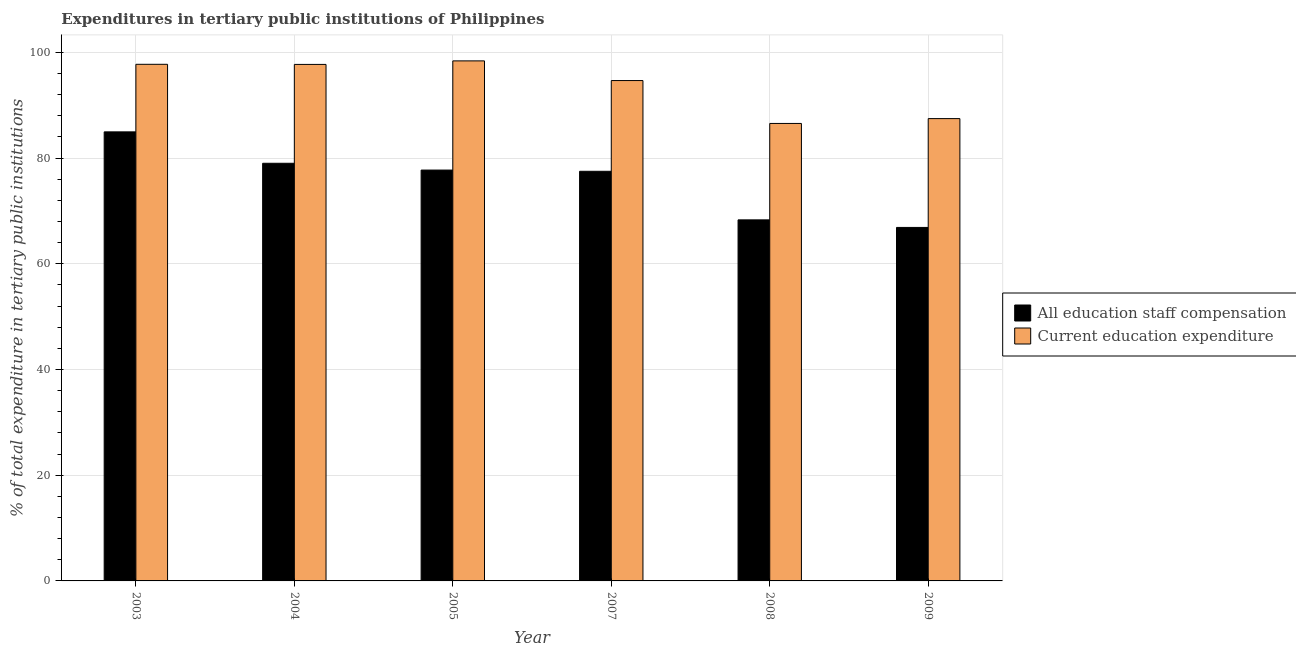How many groups of bars are there?
Provide a short and direct response. 6. Are the number of bars per tick equal to the number of legend labels?
Offer a terse response. Yes. Are the number of bars on each tick of the X-axis equal?
Your answer should be compact. Yes. How many bars are there on the 2nd tick from the left?
Ensure brevity in your answer.  2. How many bars are there on the 2nd tick from the right?
Provide a succinct answer. 2. What is the expenditure in staff compensation in 2004?
Your answer should be very brief. 79.01. Across all years, what is the maximum expenditure in education?
Your answer should be very brief. 98.39. Across all years, what is the minimum expenditure in education?
Your answer should be very brief. 86.55. What is the total expenditure in staff compensation in the graph?
Your answer should be compact. 454.38. What is the difference between the expenditure in staff compensation in 2007 and that in 2009?
Your response must be concise. 10.62. What is the difference between the expenditure in staff compensation in 2003 and the expenditure in education in 2004?
Provide a succinct answer. 5.94. What is the average expenditure in education per year?
Provide a succinct answer. 93.75. In the year 2004, what is the difference between the expenditure in education and expenditure in staff compensation?
Give a very brief answer. 0. In how many years, is the expenditure in education greater than 84 %?
Offer a very short reply. 6. What is the ratio of the expenditure in staff compensation in 2003 to that in 2005?
Provide a short and direct response. 1.09. What is the difference between the highest and the second highest expenditure in education?
Make the answer very short. 0.65. What is the difference between the highest and the lowest expenditure in staff compensation?
Offer a terse response. 18.08. What does the 1st bar from the left in 2009 represents?
Your answer should be compact. All education staff compensation. What does the 1st bar from the right in 2008 represents?
Give a very brief answer. Current education expenditure. Does the graph contain any zero values?
Provide a succinct answer. No. How many legend labels are there?
Offer a very short reply. 2. How are the legend labels stacked?
Your answer should be compact. Vertical. What is the title of the graph?
Give a very brief answer. Expenditures in tertiary public institutions of Philippines. What is the label or title of the Y-axis?
Offer a terse response. % of total expenditure in tertiary public institutions. What is the % of total expenditure in tertiary public institutions of All education staff compensation in 2003?
Provide a succinct answer. 84.95. What is the % of total expenditure in tertiary public institutions in Current education expenditure in 2003?
Your answer should be very brief. 97.74. What is the % of total expenditure in tertiary public institutions in All education staff compensation in 2004?
Offer a terse response. 79.01. What is the % of total expenditure in tertiary public institutions in Current education expenditure in 2004?
Your answer should be compact. 97.72. What is the % of total expenditure in tertiary public institutions of All education staff compensation in 2005?
Your answer should be compact. 77.73. What is the % of total expenditure in tertiary public institutions of Current education expenditure in 2005?
Your answer should be very brief. 98.39. What is the % of total expenditure in tertiary public institutions in All education staff compensation in 2007?
Provide a short and direct response. 77.5. What is the % of total expenditure in tertiary public institutions of Current education expenditure in 2007?
Ensure brevity in your answer.  94.66. What is the % of total expenditure in tertiary public institutions in All education staff compensation in 2008?
Your answer should be compact. 68.31. What is the % of total expenditure in tertiary public institutions in Current education expenditure in 2008?
Your answer should be compact. 86.55. What is the % of total expenditure in tertiary public institutions of All education staff compensation in 2009?
Your response must be concise. 66.88. What is the % of total expenditure in tertiary public institutions in Current education expenditure in 2009?
Your answer should be compact. 87.46. Across all years, what is the maximum % of total expenditure in tertiary public institutions in All education staff compensation?
Provide a succinct answer. 84.95. Across all years, what is the maximum % of total expenditure in tertiary public institutions of Current education expenditure?
Your answer should be very brief. 98.39. Across all years, what is the minimum % of total expenditure in tertiary public institutions of All education staff compensation?
Ensure brevity in your answer.  66.88. Across all years, what is the minimum % of total expenditure in tertiary public institutions of Current education expenditure?
Provide a short and direct response. 86.55. What is the total % of total expenditure in tertiary public institutions in All education staff compensation in the graph?
Provide a succinct answer. 454.38. What is the total % of total expenditure in tertiary public institutions of Current education expenditure in the graph?
Your answer should be very brief. 562.51. What is the difference between the % of total expenditure in tertiary public institutions of All education staff compensation in 2003 and that in 2004?
Offer a very short reply. 5.94. What is the difference between the % of total expenditure in tertiary public institutions in Current education expenditure in 2003 and that in 2004?
Your answer should be compact. 0.02. What is the difference between the % of total expenditure in tertiary public institutions of All education staff compensation in 2003 and that in 2005?
Give a very brief answer. 7.23. What is the difference between the % of total expenditure in tertiary public institutions of Current education expenditure in 2003 and that in 2005?
Your answer should be very brief. -0.65. What is the difference between the % of total expenditure in tertiary public institutions in All education staff compensation in 2003 and that in 2007?
Provide a succinct answer. 7.46. What is the difference between the % of total expenditure in tertiary public institutions in Current education expenditure in 2003 and that in 2007?
Your answer should be very brief. 3.07. What is the difference between the % of total expenditure in tertiary public institutions in All education staff compensation in 2003 and that in 2008?
Ensure brevity in your answer.  16.65. What is the difference between the % of total expenditure in tertiary public institutions in Current education expenditure in 2003 and that in 2008?
Ensure brevity in your answer.  11.19. What is the difference between the % of total expenditure in tertiary public institutions of All education staff compensation in 2003 and that in 2009?
Ensure brevity in your answer.  18.08. What is the difference between the % of total expenditure in tertiary public institutions of Current education expenditure in 2003 and that in 2009?
Your response must be concise. 10.27. What is the difference between the % of total expenditure in tertiary public institutions in All education staff compensation in 2004 and that in 2005?
Give a very brief answer. 1.28. What is the difference between the % of total expenditure in tertiary public institutions in Current education expenditure in 2004 and that in 2005?
Offer a terse response. -0.67. What is the difference between the % of total expenditure in tertiary public institutions of All education staff compensation in 2004 and that in 2007?
Make the answer very short. 1.52. What is the difference between the % of total expenditure in tertiary public institutions of Current education expenditure in 2004 and that in 2007?
Ensure brevity in your answer.  3.05. What is the difference between the % of total expenditure in tertiary public institutions in All education staff compensation in 2004 and that in 2008?
Offer a terse response. 10.71. What is the difference between the % of total expenditure in tertiary public institutions of Current education expenditure in 2004 and that in 2008?
Your answer should be compact. 11.17. What is the difference between the % of total expenditure in tertiary public institutions of All education staff compensation in 2004 and that in 2009?
Provide a succinct answer. 12.14. What is the difference between the % of total expenditure in tertiary public institutions in Current education expenditure in 2004 and that in 2009?
Keep it short and to the point. 10.25. What is the difference between the % of total expenditure in tertiary public institutions in All education staff compensation in 2005 and that in 2007?
Your answer should be compact. 0.23. What is the difference between the % of total expenditure in tertiary public institutions in Current education expenditure in 2005 and that in 2007?
Your response must be concise. 3.72. What is the difference between the % of total expenditure in tertiary public institutions in All education staff compensation in 2005 and that in 2008?
Offer a terse response. 9.42. What is the difference between the % of total expenditure in tertiary public institutions of Current education expenditure in 2005 and that in 2008?
Your answer should be compact. 11.84. What is the difference between the % of total expenditure in tertiary public institutions of All education staff compensation in 2005 and that in 2009?
Make the answer very short. 10.85. What is the difference between the % of total expenditure in tertiary public institutions in Current education expenditure in 2005 and that in 2009?
Provide a succinct answer. 10.92. What is the difference between the % of total expenditure in tertiary public institutions in All education staff compensation in 2007 and that in 2008?
Give a very brief answer. 9.19. What is the difference between the % of total expenditure in tertiary public institutions of Current education expenditure in 2007 and that in 2008?
Make the answer very short. 8.11. What is the difference between the % of total expenditure in tertiary public institutions in All education staff compensation in 2007 and that in 2009?
Keep it short and to the point. 10.62. What is the difference between the % of total expenditure in tertiary public institutions of Current education expenditure in 2007 and that in 2009?
Make the answer very short. 7.2. What is the difference between the % of total expenditure in tertiary public institutions of All education staff compensation in 2008 and that in 2009?
Your answer should be very brief. 1.43. What is the difference between the % of total expenditure in tertiary public institutions of Current education expenditure in 2008 and that in 2009?
Provide a succinct answer. -0.91. What is the difference between the % of total expenditure in tertiary public institutions of All education staff compensation in 2003 and the % of total expenditure in tertiary public institutions of Current education expenditure in 2004?
Your answer should be compact. -12.76. What is the difference between the % of total expenditure in tertiary public institutions in All education staff compensation in 2003 and the % of total expenditure in tertiary public institutions in Current education expenditure in 2005?
Offer a very short reply. -13.43. What is the difference between the % of total expenditure in tertiary public institutions in All education staff compensation in 2003 and the % of total expenditure in tertiary public institutions in Current education expenditure in 2007?
Keep it short and to the point. -9.71. What is the difference between the % of total expenditure in tertiary public institutions of All education staff compensation in 2003 and the % of total expenditure in tertiary public institutions of Current education expenditure in 2008?
Offer a terse response. -1.6. What is the difference between the % of total expenditure in tertiary public institutions of All education staff compensation in 2003 and the % of total expenditure in tertiary public institutions of Current education expenditure in 2009?
Your answer should be very brief. -2.51. What is the difference between the % of total expenditure in tertiary public institutions of All education staff compensation in 2004 and the % of total expenditure in tertiary public institutions of Current education expenditure in 2005?
Offer a very short reply. -19.37. What is the difference between the % of total expenditure in tertiary public institutions of All education staff compensation in 2004 and the % of total expenditure in tertiary public institutions of Current education expenditure in 2007?
Provide a succinct answer. -15.65. What is the difference between the % of total expenditure in tertiary public institutions of All education staff compensation in 2004 and the % of total expenditure in tertiary public institutions of Current education expenditure in 2008?
Your response must be concise. -7.54. What is the difference between the % of total expenditure in tertiary public institutions of All education staff compensation in 2004 and the % of total expenditure in tertiary public institutions of Current education expenditure in 2009?
Ensure brevity in your answer.  -8.45. What is the difference between the % of total expenditure in tertiary public institutions in All education staff compensation in 2005 and the % of total expenditure in tertiary public institutions in Current education expenditure in 2007?
Your answer should be compact. -16.93. What is the difference between the % of total expenditure in tertiary public institutions of All education staff compensation in 2005 and the % of total expenditure in tertiary public institutions of Current education expenditure in 2008?
Your answer should be very brief. -8.82. What is the difference between the % of total expenditure in tertiary public institutions in All education staff compensation in 2005 and the % of total expenditure in tertiary public institutions in Current education expenditure in 2009?
Your response must be concise. -9.74. What is the difference between the % of total expenditure in tertiary public institutions in All education staff compensation in 2007 and the % of total expenditure in tertiary public institutions in Current education expenditure in 2008?
Offer a very short reply. -9.05. What is the difference between the % of total expenditure in tertiary public institutions in All education staff compensation in 2007 and the % of total expenditure in tertiary public institutions in Current education expenditure in 2009?
Give a very brief answer. -9.97. What is the difference between the % of total expenditure in tertiary public institutions of All education staff compensation in 2008 and the % of total expenditure in tertiary public institutions of Current education expenditure in 2009?
Ensure brevity in your answer.  -19.16. What is the average % of total expenditure in tertiary public institutions in All education staff compensation per year?
Offer a terse response. 75.73. What is the average % of total expenditure in tertiary public institutions of Current education expenditure per year?
Your response must be concise. 93.75. In the year 2003, what is the difference between the % of total expenditure in tertiary public institutions of All education staff compensation and % of total expenditure in tertiary public institutions of Current education expenditure?
Provide a short and direct response. -12.78. In the year 2004, what is the difference between the % of total expenditure in tertiary public institutions in All education staff compensation and % of total expenditure in tertiary public institutions in Current education expenditure?
Your answer should be very brief. -18.7. In the year 2005, what is the difference between the % of total expenditure in tertiary public institutions of All education staff compensation and % of total expenditure in tertiary public institutions of Current education expenditure?
Your answer should be very brief. -20.66. In the year 2007, what is the difference between the % of total expenditure in tertiary public institutions in All education staff compensation and % of total expenditure in tertiary public institutions in Current education expenditure?
Your answer should be compact. -17.16. In the year 2008, what is the difference between the % of total expenditure in tertiary public institutions in All education staff compensation and % of total expenditure in tertiary public institutions in Current education expenditure?
Your answer should be very brief. -18.24. In the year 2009, what is the difference between the % of total expenditure in tertiary public institutions of All education staff compensation and % of total expenditure in tertiary public institutions of Current education expenditure?
Give a very brief answer. -20.59. What is the ratio of the % of total expenditure in tertiary public institutions of All education staff compensation in 2003 to that in 2004?
Provide a succinct answer. 1.08. What is the ratio of the % of total expenditure in tertiary public institutions in All education staff compensation in 2003 to that in 2005?
Provide a succinct answer. 1.09. What is the ratio of the % of total expenditure in tertiary public institutions of All education staff compensation in 2003 to that in 2007?
Your response must be concise. 1.1. What is the ratio of the % of total expenditure in tertiary public institutions in Current education expenditure in 2003 to that in 2007?
Provide a short and direct response. 1.03. What is the ratio of the % of total expenditure in tertiary public institutions of All education staff compensation in 2003 to that in 2008?
Your response must be concise. 1.24. What is the ratio of the % of total expenditure in tertiary public institutions of Current education expenditure in 2003 to that in 2008?
Provide a succinct answer. 1.13. What is the ratio of the % of total expenditure in tertiary public institutions of All education staff compensation in 2003 to that in 2009?
Make the answer very short. 1.27. What is the ratio of the % of total expenditure in tertiary public institutions in Current education expenditure in 2003 to that in 2009?
Offer a very short reply. 1.12. What is the ratio of the % of total expenditure in tertiary public institutions in All education staff compensation in 2004 to that in 2005?
Provide a succinct answer. 1.02. What is the ratio of the % of total expenditure in tertiary public institutions in Current education expenditure in 2004 to that in 2005?
Keep it short and to the point. 0.99. What is the ratio of the % of total expenditure in tertiary public institutions in All education staff compensation in 2004 to that in 2007?
Ensure brevity in your answer.  1.02. What is the ratio of the % of total expenditure in tertiary public institutions in Current education expenditure in 2004 to that in 2007?
Offer a terse response. 1.03. What is the ratio of the % of total expenditure in tertiary public institutions of All education staff compensation in 2004 to that in 2008?
Your response must be concise. 1.16. What is the ratio of the % of total expenditure in tertiary public institutions of Current education expenditure in 2004 to that in 2008?
Your answer should be compact. 1.13. What is the ratio of the % of total expenditure in tertiary public institutions in All education staff compensation in 2004 to that in 2009?
Provide a short and direct response. 1.18. What is the ratio of the % of total expenditure in tertiary public institutions in Current education expenditure in 2004 to that in 2009?
Your answer should be very brief. 1.12. What is the ratio of the % of total expenditure in tertiary public institutions in Current education expenditure in 2005 to that in 2007?
Offer a terse response. 1.04. What is the ratio of the % of total expenditure in tertiary public institutions in All education staff compensation in 2005 to that in 2008?
Your answer should be compact. 1.14. What is the ratio of the % of total expenditure in tertiary public institutions in Current education expenditure in 2005 to that in 2008?
Give a very brief answer. 1.14. What is the ratio of the % of total expenditure in tertiary public institutions of All education staff compensation in 2005 to that in 2009?
Provide a succinct answer. 1.16. What is the ratio of the % of total expenditure in tertiary public institutions in Current education expenditure in 2005 to that in 2009?
Offer a very short reply. 1.12. What is the ratio of the % of total expenditure in tertiary public institutions of All education staff compensation in 2007 to that in 2008?
Your answer should be very brief. 1.13. What is the ratio of the % of total expenditure in tertiary public institutions of Current education expenditure in 2007 to that in 2008?
Keep it short and to the point. 1.09. What is the ratio of the % of total expenditure in tertiary public institutions in All education staff compensation in 2007 to that in 2009?
Offer a terse response. 1.16. What is the ratio of the % of total expenditure in tertiary public institutions of Current education expenditure in 2007 to that in 2009?
Your answer should be compact. 1.08. What is the ratio of the % of total expenditure in tertiary public institutions of All education staff compensation in 2008 to that in 2009?
Provide a short and direct response. 1.02. What is the ratio of the % of total expenditure in tertiary public institutions in Current education expenditure in 2008 to that in 2009?
Provide a succinct answer. 0.99. What is the difference between the highest and the second highest % of total expenditure in tertiary public institutions of All education staff compensation?
Keep it short and to the point. 5.94. What is the difference between the highest and the second highest % of total expenditure in tertiary public institutions in Current education expenditure?
Your response must be concise. 0.65. What is the difference between the highest and the lowest % of total expenditure in tertiary public institutions of All education staff compensation?
Keep it short and to the point. 18.08. What is the difference between the highest and the lowest % of total expenditure in tertiary public institutions of Current education expenditure?
Your answer should be very brief. 11.84. 